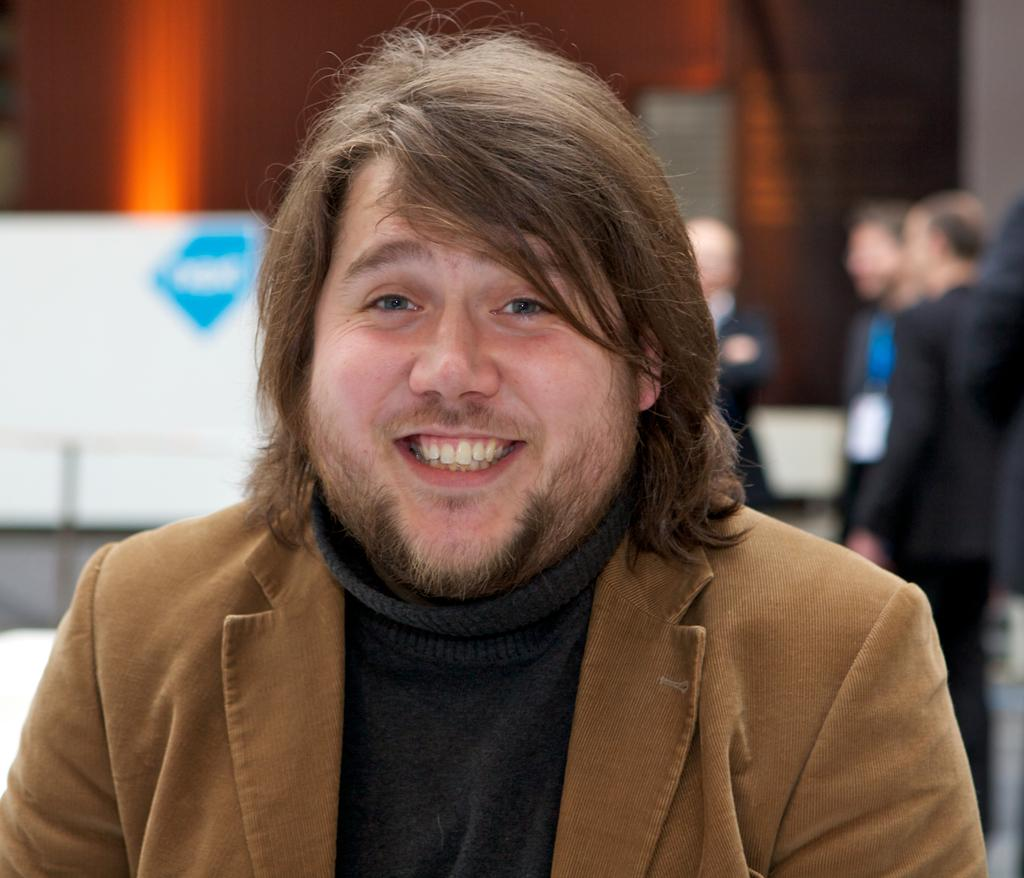Who is present in the image? There is a man in the image. What is the man wearing on his upper body? The man is wearing a brown blazer and a black sweater. Are there any other people wearing similar clothing in the image? Yes, there are people wearing blazers towards the right side of the image. What type of hydrant can be seen in the wilderness during the month of June in the image? There is no hydrant, wilderness, or specific month mentioned in the image. 